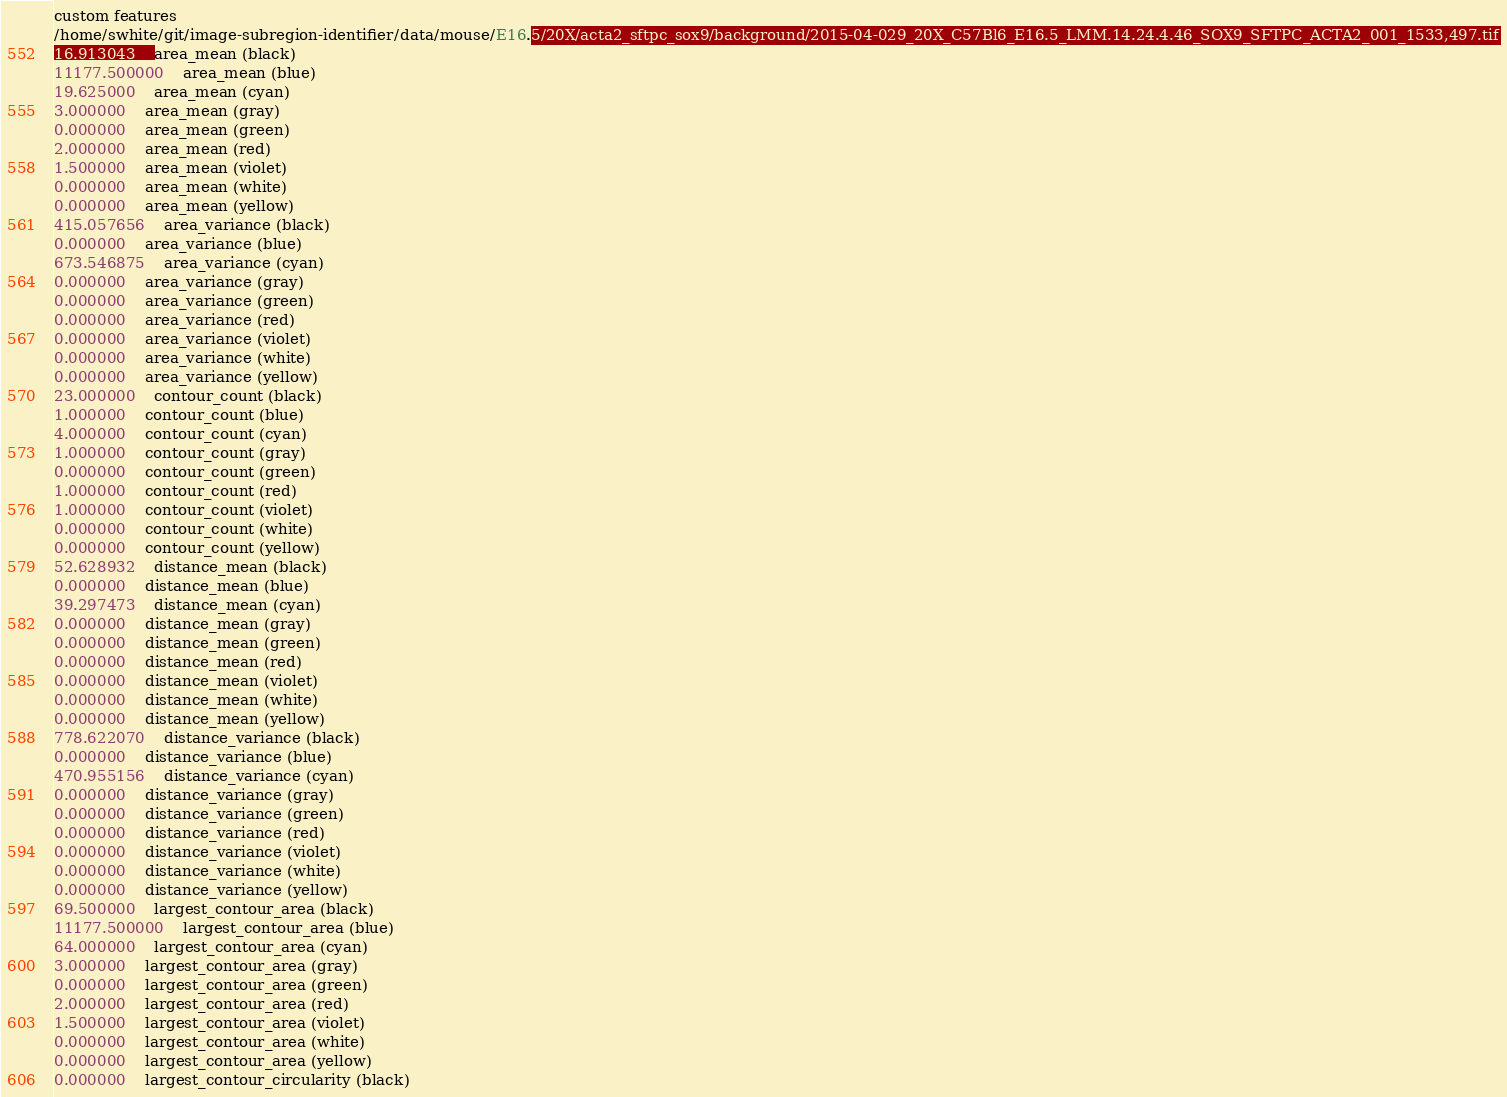Convert code to text. <code><loc_0><loc_0><loc_500><loc_500><_SML_>custom features
/home/swhite/git/image-subregion-identifier/data/mouse/E16.5/20X/acta2_sftpc_sox9/background/2015-04-029_20X_C57Bl6_E16.5_LMM.14.24.4.46_SOX9_SFTPC_ACTA2_001_1533,497.tif
16.913043	area_mean (black)
11177.500000	area_mean (blue)
19.625000	area_mean (cyan)
3.000000	area_mean (gray)
0.000000	area_mean (green)
2.000000	area_mean (red)
1.500000	area_mean (violet)
0.000000	area_mean (white)
0.000000	area_mean (yellow)
415.057656	area_variance (black)
0.000000	area_variance (blue)
673.546875	area_variance (cyan)
0.000000	area_variance (gray)
0.000000	area_variance (green)
0.000000	area_variance (red)
0.000000	area_variance (violet)
0.000000	area_variance (white)
0.000000	area_variance (yellow)
23.000000	contour_count (black)
1.000000	contour_count (blue)
4.000000	contour_count (cyan)
1.000000	contour_count (gray)
0.000000	contour_count (green)
1.000000	contour_count (red)
1.000000	contour_count (violet)
0.000000	contour_count (white)
0.000000	contour_count (yellow)
52.628932	distance_mean (black)
0.000000	distance_mean (blue)
39.297473	distance_mean (cyan)
0.000000	distance_mean (gray)
0.000000	distance_mean (green)
0.000000	distance_mean (red)
0.000000	distance_mean (violet)
0.000000	distance_mean (white)
0.000000	distance_mean (yellow)
778.622070	distance_variance (black)
0.000000	distance_variance (blue)
470.955156	distance_variance (cyan)
0.000000	distance_variance (gray)
0.000000	distance_variance (green)
0.000000	distance_variance (red)
0.000000	distance_variance (violet)
0.000000	distance_variance (white)
0.000000	distance_variance (yellow)
69.500000	largest_contour_area (black)
11177.500000	largest_contour_area (blue)
64.000000	largest_contour_area (cyan)
3.000000	largest_contour_area (gray)
0.000000	largest_contour_area (green)
2.000000	largest_contour_area (red)
1.500000	largest_contour_area (violet)
0.000000	largest_contour_area (white)
0.000000	largest_contour_area (yellow)
0.000000	largest_contour_circularity (black)</code> 